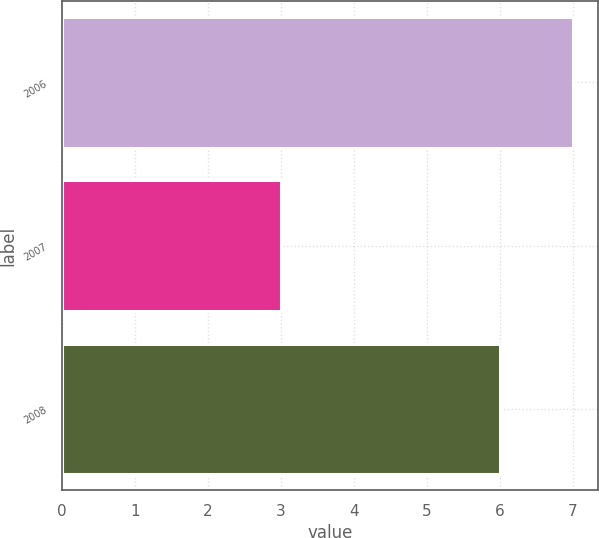<chart> <loc_0><loc_0><loc_500><loc_500><bar_chart><fcel>2006<fcel>2007<fcel>2008<nl><fcel>7<fcel>3<fcel>6<nl></chart> 